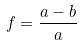<formula> <loc_0><loc_0><loc_500><loc_500>f = \frac { a - b } { a }</formula> 